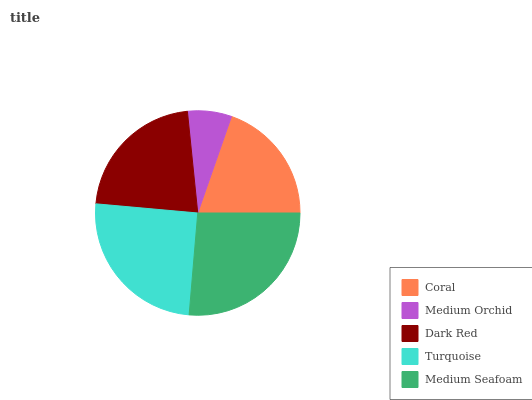Is Medium Orchid the minimum?
Answer yes or no. Yes. Is Medium Seafoam the maximum?
Answer yes or no. Yes. Is Dark Red the minimum?
Answer yes or no. No. Is Dark Red the maximum?
Answer yes or no. No. Is Dark Red greater than Medium Orchid?
Answer yes or no. Yes. Is Medium Orchid less than Dark Red?
Answer yes or no. Yes. Is Medium Orchid greater than Dark Red?
Answer yes or no. No. Is Dark Red less than Medium Orchid?
Answer yes or no. No. Is Dark Red the high median?
Answer yes or no. Yes. Is Dark Red the low median?
Answer yes or no. Yes. Is Turquoise the high median?
Answer yes or no. No. Is Coral the low median?
Answer yes or no. No. 